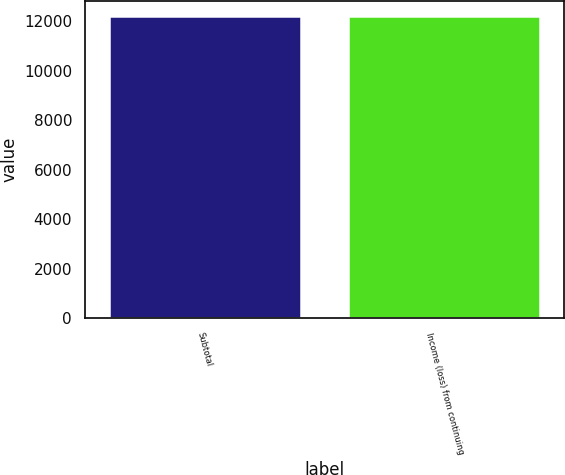Convert chart to OTSL. <chart><loc_0><loc_0><loc_500><loc_500><bar_chart><fcel>Subtotal<fcel>Income (loss) from continuing<nl><fcel>12225<fcel>12225.1<nl></chart> 